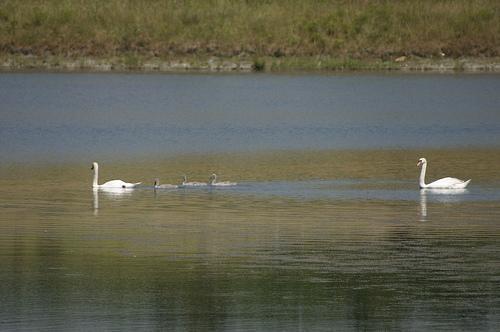How many ducks are in the photo?
Give a very brief answer. 5. 